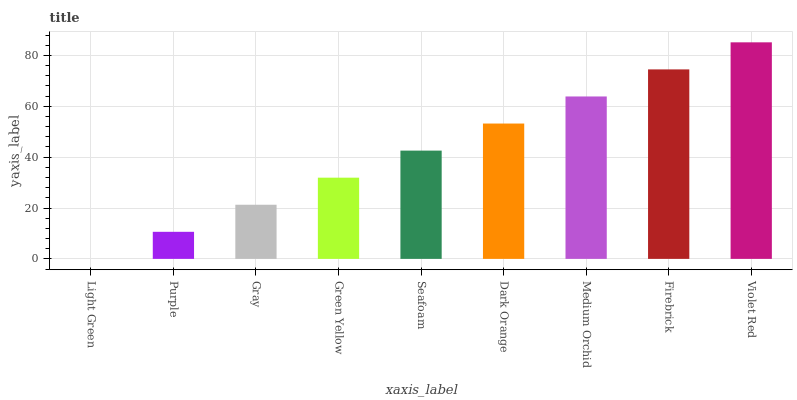Is Purple the minimum?
Answer yes or no. No. Is Purple the maximum?
Answer yes or no. No. Is Purple greater than Light Green?
Answer yes or no. Yes. Is Light Green less than Purple?
Answer yes or no. Yes. Is Light Green greater than Purple?
Answer yes or no. No. Is Purple less than Light Green?
Answer yes or no. No. Is Seafoam the high median?
Answer yes or no. Yes. Is Seafoam the low median?
Answer yes or no. Yes. Is Firebrick the high median?
Answer yes or no. No. Is Light Green the low median?
Answer yes or no. No. 